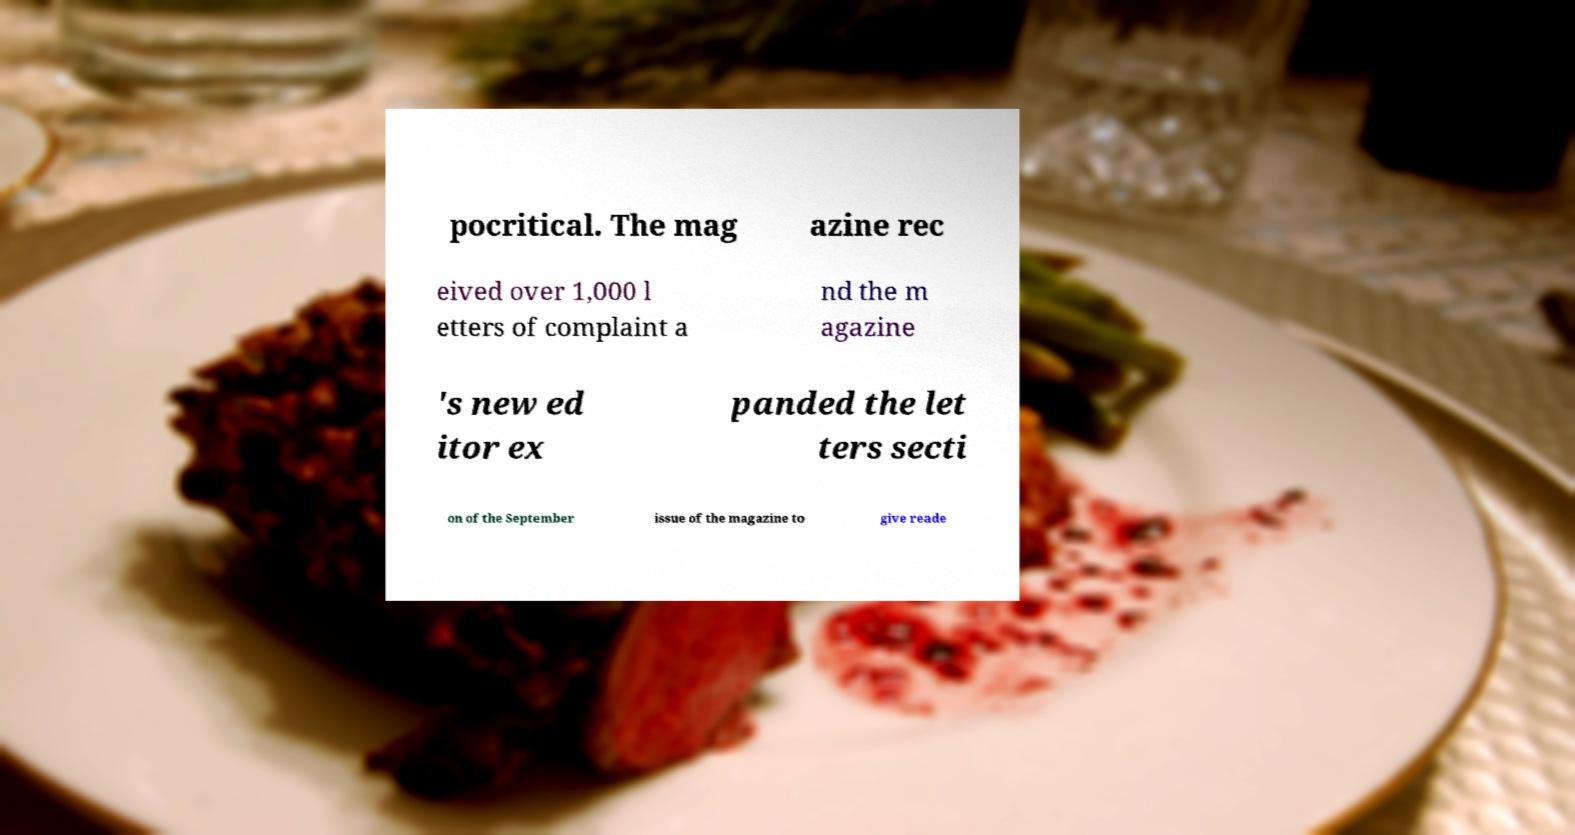For documentation purposes, I need the text within this image transcribed. Could you provide that? pocritical. The mag azine rec eived over 1,000 l etters of complaint a nd the m agazine 's new ed itor ex panded the let ters secti on of the September issue of the magazine to give reade 